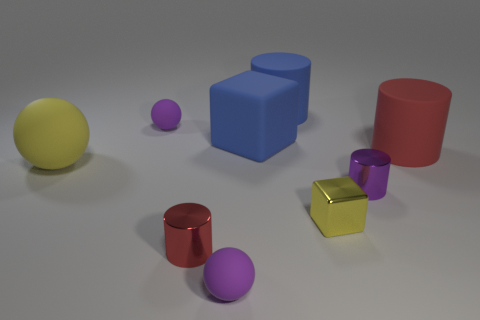What is the material of the other big object that is the same shape as the yellow metallic object?
Provide a short and direct response. Rubber. Is there any other thing that has the same material as the blue block?
Your answer should be compact. Yes. How many other objects are there of the same shape as the tiny red object?
Your answer should be compact. 3. There is a tiny yellow metallic block on the right side of the tiny ball that is in front of the tiny block; how many yellow rubber spheres are in front of it?
Your answer should be compact. 0. What number of other things are the same shape as the small yellow thing?
Your answer should be very brief. 1. Do the tiny cylinder that is on the right side of the blue cylinder and the large matte block have the same color?
Your answer should be compact. No. The blue matte object that is in front of the tiny matte sphere to the left of the small ball that is in front of the red metallic object is what shape?
Offer a very short reply. Cube. Does the blue rubber cylinder have the same size as the cube in front of the tiny purple shiny object?
Provide a short and direct response. No. Is there a matte object that has the same size as the yellow metal object?
Your response must be concise. Yes. How many other things are the same material as the big red cylinder?
Keep it short and to the point. 5. 